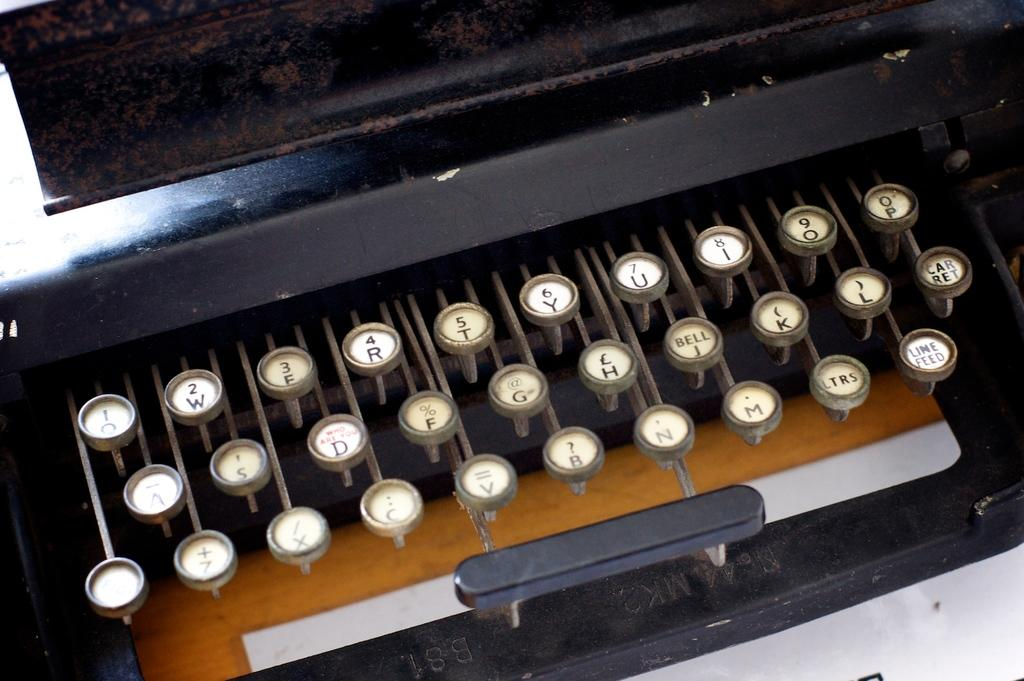<image>
Relay a brief, clear account of the picture shown. An old antique manual typewriter that says No. 44 under the space bar. 